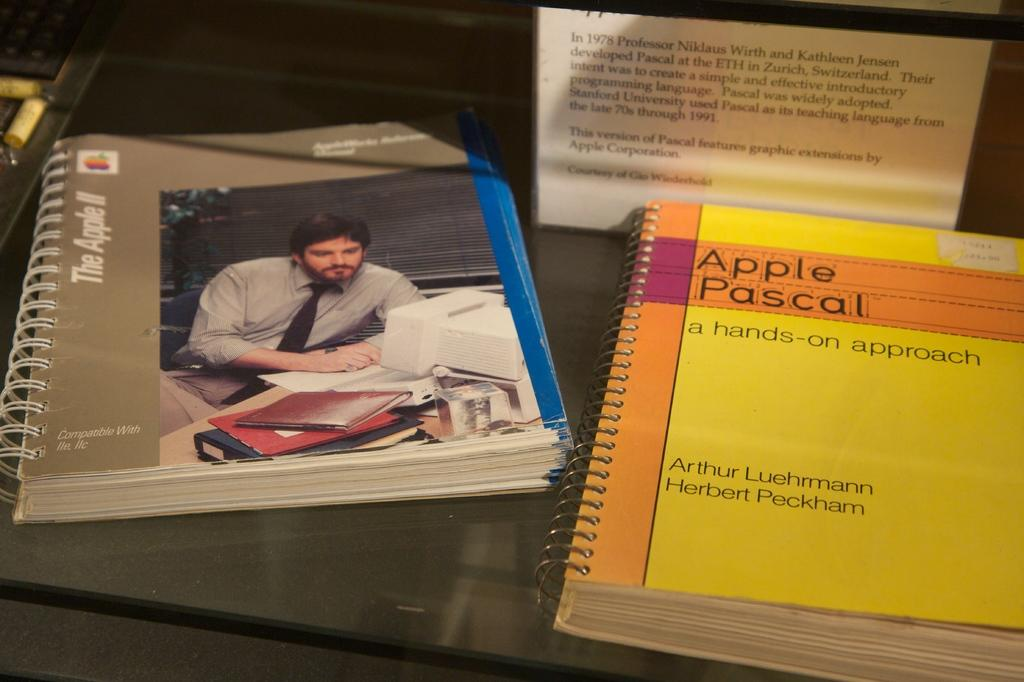<image>
Render a clear and concise summary of the photo. Booklet showing a man next to another booklet that says Apple Pascal. 